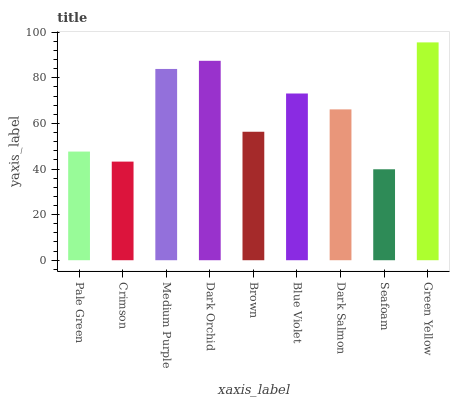Is Seafoam the minimum?
Answer yes or no. Yes. Is Green Yellow the maximum?
Answer yes or no. Yes. Is Crimson the minimum?
Answer yes or no. No. Is Crimson the maximum?
Answer yes or no. No. Is Pale Green greater than Crimson?
Answer yes or no. Yes. Is Crimson less than Pale Green?
Answer yes or no. Yes. Is Crimson greater than Pale Green?
Answer yes or no. No. Is Pale Green less than Crimson?
Answer yes or no. No. Is Dark Salmon the high median?
Answer yes or no. Yes. Is Dark Salmon the low median?
Answer yes or no. Yes. Is Green Yellow the high median?
Answer yes or no. No. Is Medium Purple the low median?
Answer yes or no. No. 